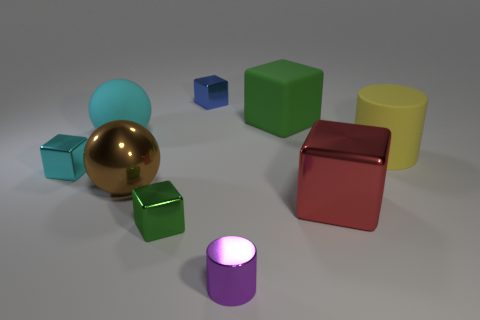Can you describe the shapes and materials of the objects in the image? Certainly! In the image, there are various geometric shapes including cubes, a sphere, and cylinders. These objects appear to be made of different materials as indicated by their textures and reflections. The cubes and cylinders have a matte, rubber-like surface, whereas the sphere has a glossy, metallic finish. Which object stands out the most to you? The golden sphere stands out due to its shiny, reflective surface which contrasts with the matte textures of the other objects, making it a focal point in the image. 